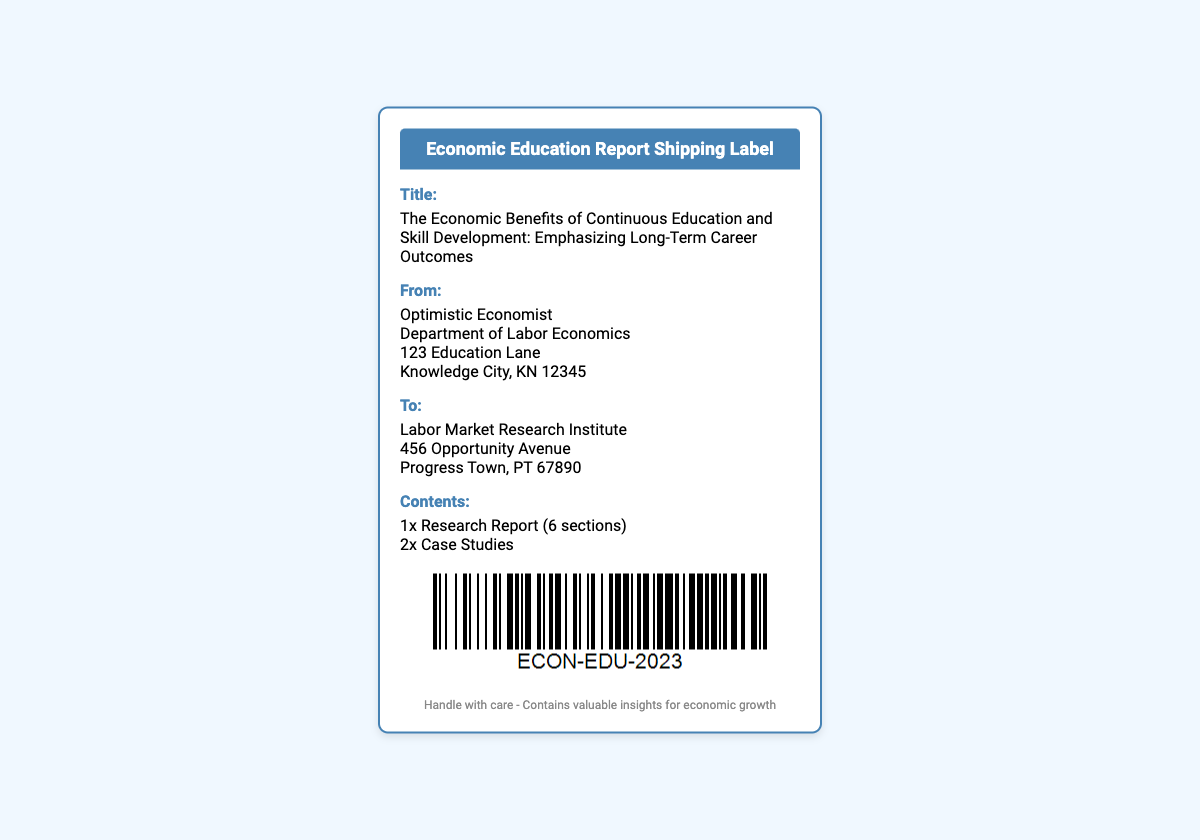What is the title of the report? The title is prominently listed in the document under "Title."
Answer: The Economic Benefits of Continuous Education and Skill Development: Emphasizing Long-Term Career Outcomes Who is the sender of the document? The sender's information is provided under "From," which includes a name and department.
Answer: Optimistic Economist What is the address of the sender? The sender's address is detailed in the document and consists of a street address, city, and postal code.
Answer: 123 Education Lane, Knowledge City, KN 12345 How many case studies are included in the contents? The number of case studies is listed in the "Contents" section of the document.
Answer: 2x Case Studies What is the recipient institution's name? The name of the recipient is specified under "To."
Answer: Labor Market Research Institute What message is conveyed in the footer? The footer consists of a brief note or message indicating the contents of the shipping label.
Answer: Handle with care - Contains valuable insights for economic growth What is the document type? The document is identified as a shipping label, as indicated in the header.
Answer: Shipping Label How many sections does the research report contain? The number of sections in the report is specified in the "Contents" section.
Answer: 6 sections 